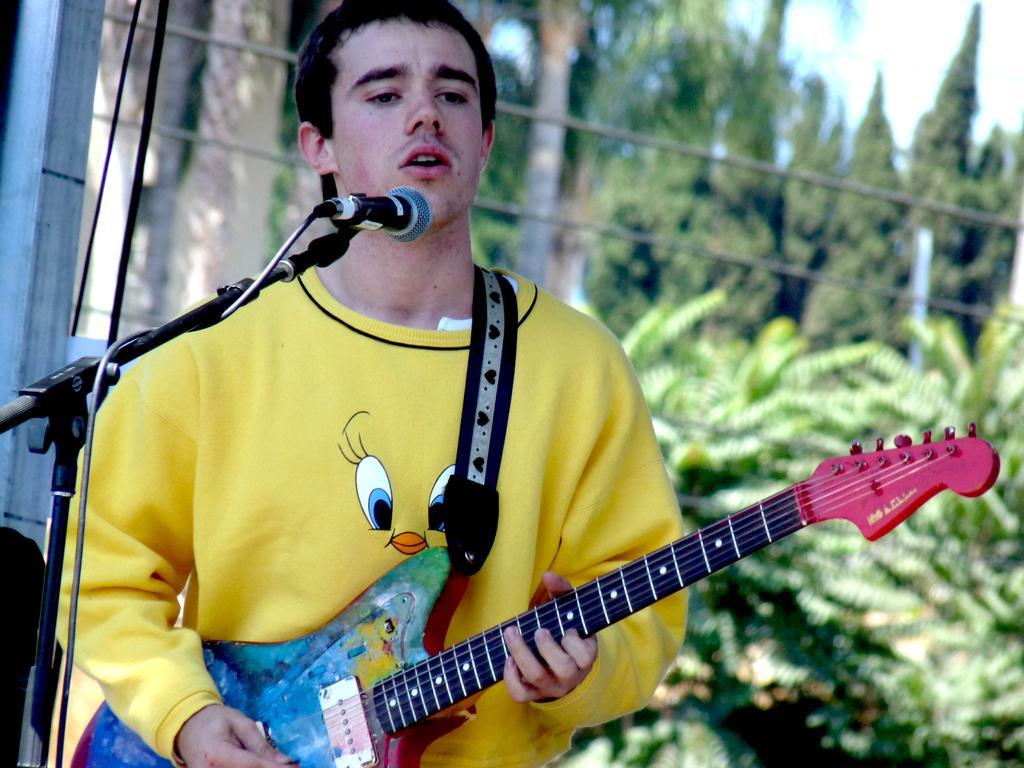Can you describe this image briefly? In this image there is one person who is standing and he is holding a guitar and he is wearing a yellow t shirt, in front of him there is one mike it seems that he is singing. On the right side of the image there are some trees and sky. 